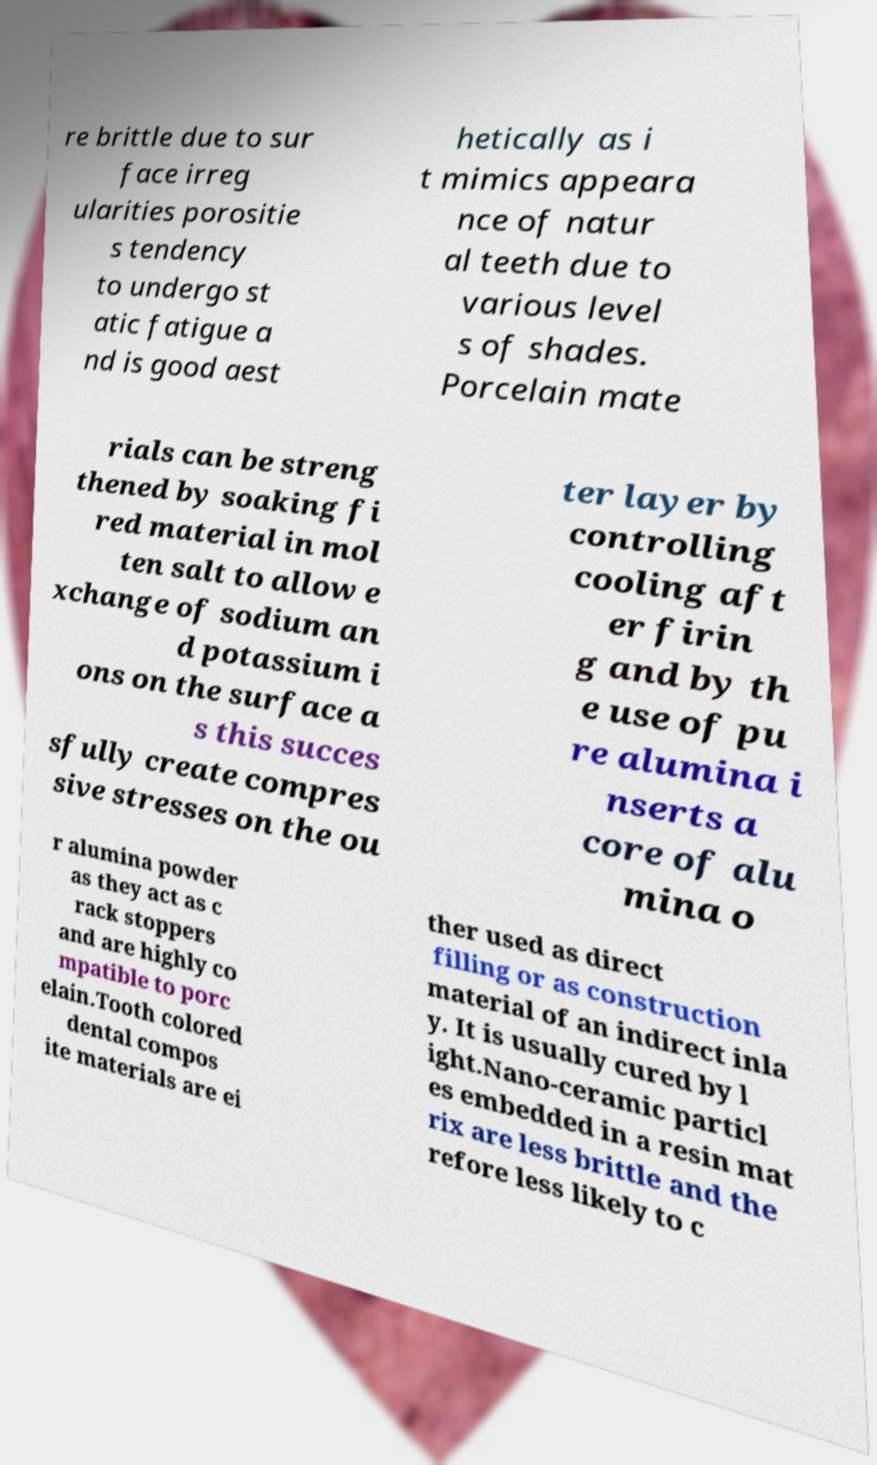For documentation purposes, I need the text within this image transcribed. Could you provide that? re brittle due to sur face irreg ularities porositie s tendency to undergo st atic fatigue a nd is good aest hetically as i t mimics appeara nce of natur al teeth due to various level s of shades. Porcelain mate rials can be streng thened by soaking fi red material in mol ten salt to allow e xchange of sodium an d potassium i ons on the surface a s this succes sfully create compres sive stresses on the ou ter layer by controlling cooling aft er firin g and by th e use of pu re alumina i nserts a core of alu mina o r alumina powder as they act as c rack stoppers and are highly co mpatible to porc elain.Tooth colored dental compos ite materials are ei ther used as direct filling or as construction material of an indirect inla y. It is usually cured by l ight.Nano-ceramic particl es embedded in a resin mat rix are less brittle and the refore less likely to c 